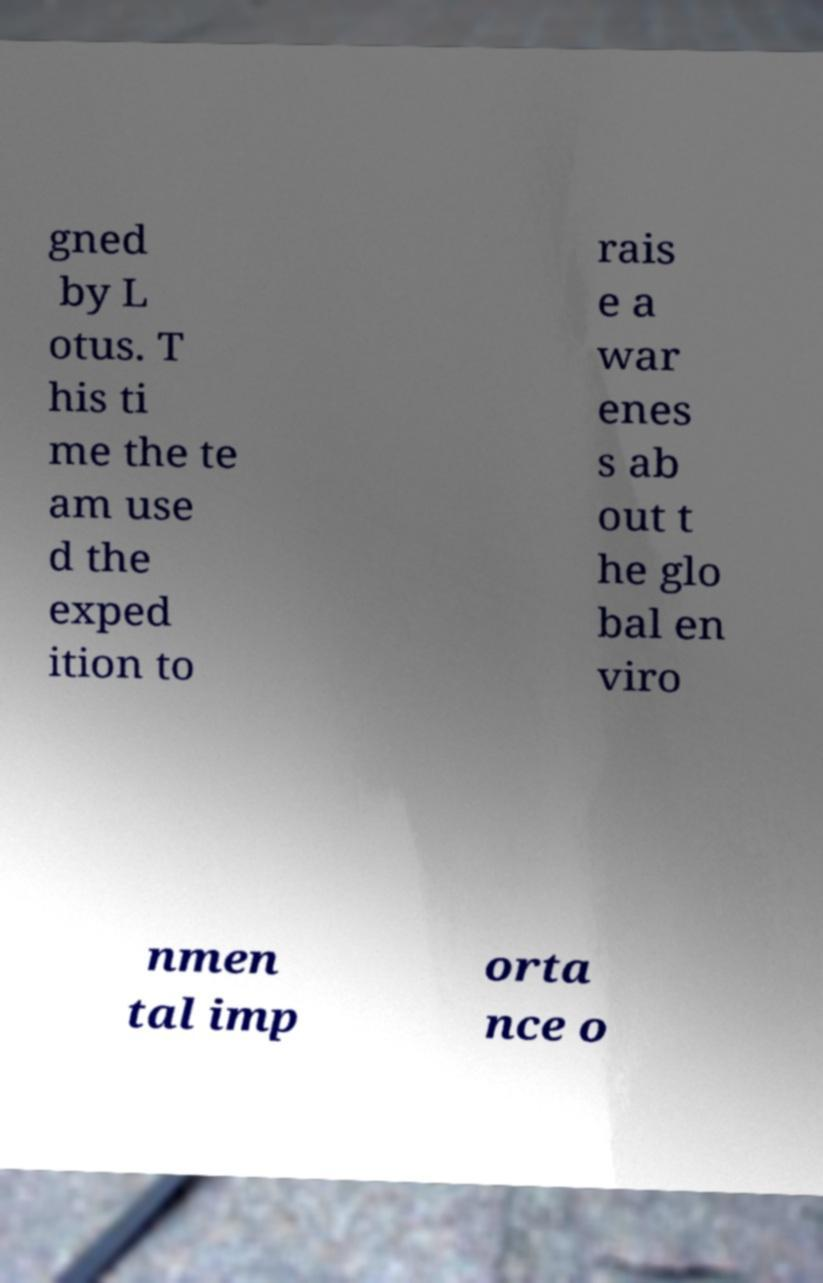There's text embedded in this image that I need extracted. Can you transcribe it verbatim? gned by L otus. T his ti me the te am use d the exped ition to rais e a war enes s ab out t he glo bal en viro nmen tal imp orta nce o 